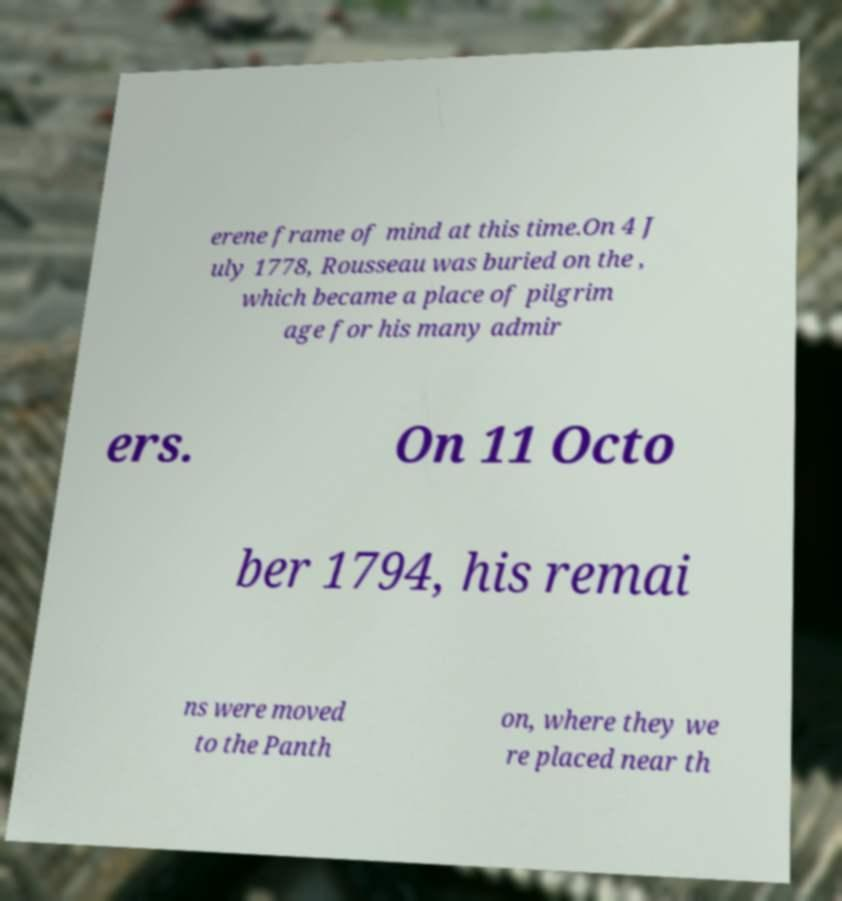Can you accurately transcribe the text from the provided image for me? erene frame of mind at this time.On 4 J uly 1778, Rousseau was buried on the , which became a place of pilgrim age for his many admir ers. On 11 Octo ber 1794, his remai ns were moved to the Panth on, where they we re placed near th 